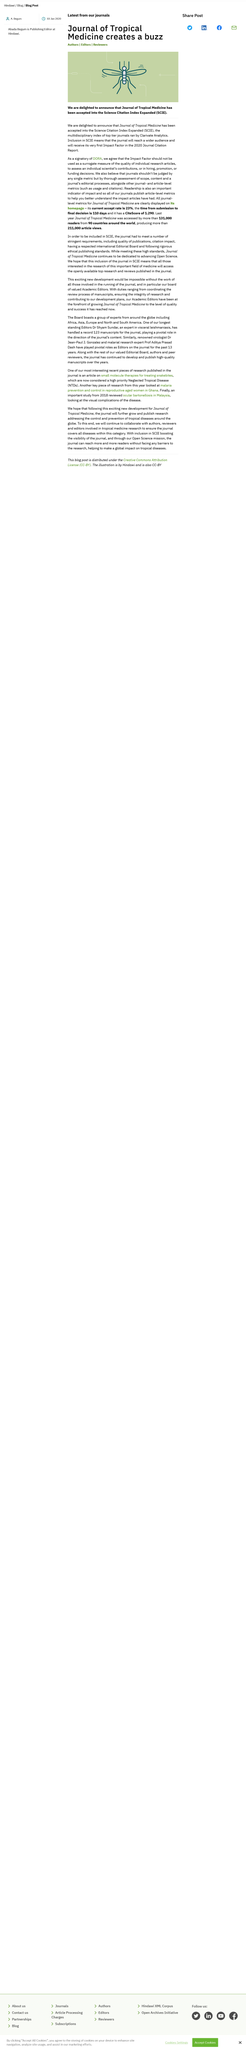Draw attention to some important aspects in this diagram. Journal-level metrics for the Journal of Tropical Medicine are available on its homepage. The Journal of Tropical Medicine has been accepted into the Science Citation Index Expanded (SCIE). Last year, the Journal of Tropical Medicine was read by readers from 90 countries. 